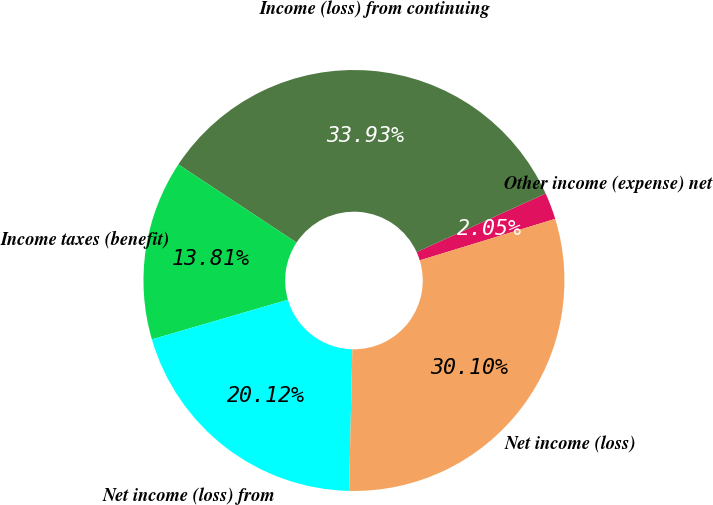<chart> <loc_0><loc_0><loc_500><loc_500><pie_chart><fcel>Other income (expense) net<fcel>Income (loss) from continuing<fcel>Income taxes (benefit)<fcel>Net income (loss) from<fcel>Net income (loss)<nl><fcel>2.05%<fcel>33.93%<fcel>13.81%<fcel>20.12%<fcel>30.1%<nl></chart> 